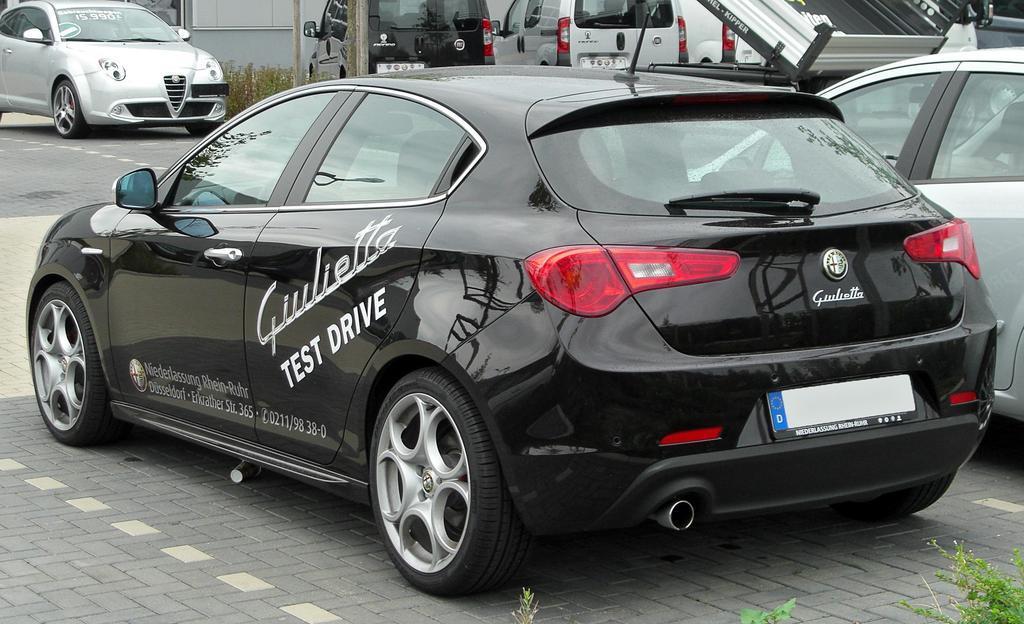Describe this image in one or two sentences. In this image there are vehicles in the front, at the bottom of the image there are leaves. In the background there is a wall and there are plants in front of the wall and there is some text written on the car which is in the front. 